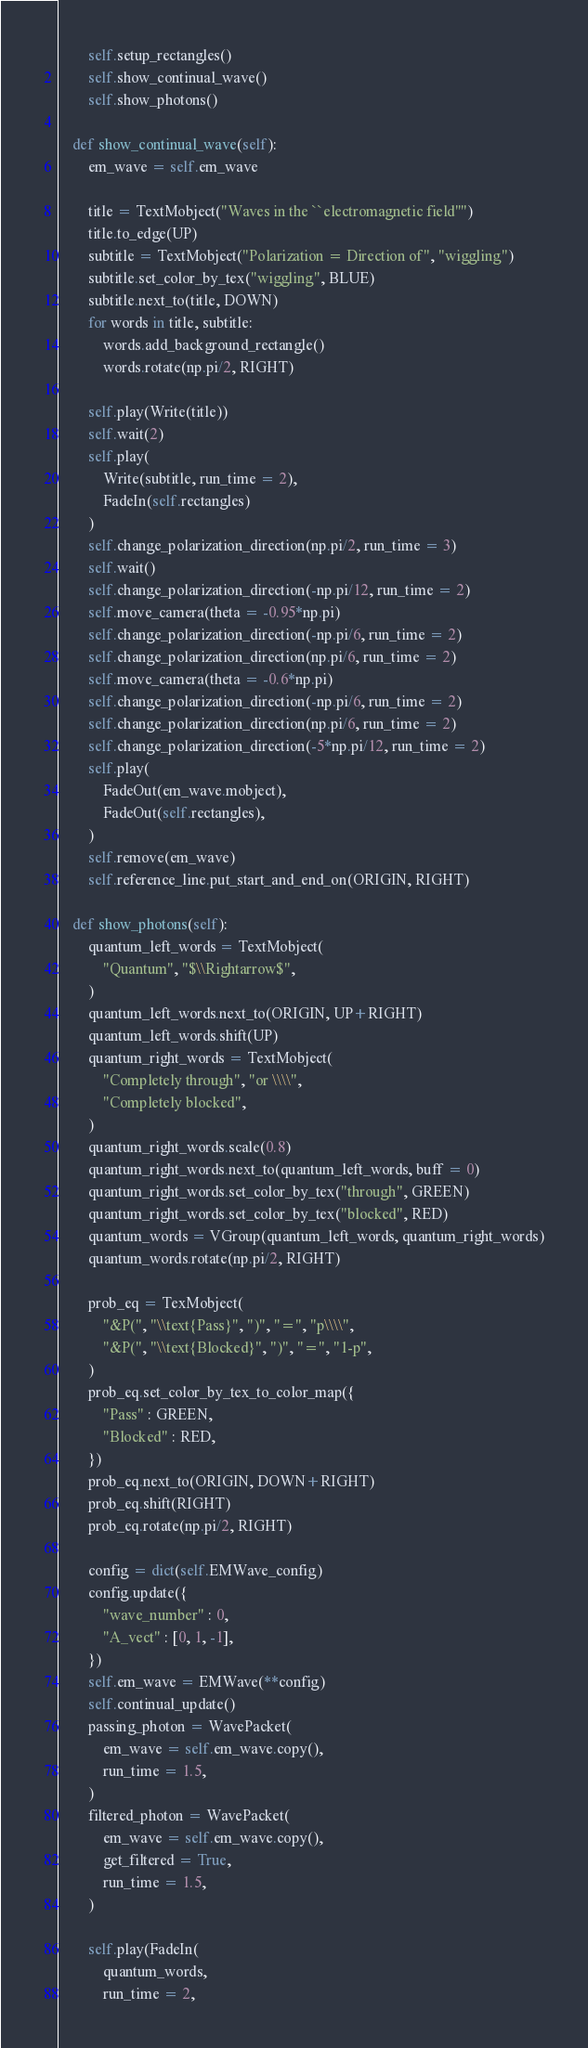Convert code to text. <code><loc_0><loc_0><loc_500><loc_500><_Python_>        self.setup_rectangles()
        self.show_continual_wave()
        self.show_photons()

    def show_continual_wave(self):
        em_wave = self.em_wave

        title = TextMobject("Waves in the ``electromagnetic field''")
        title.to_edge(UP)
        subtitle = TextMobject("Polarization = Direction of", "wiggling")
        subtitle.set_color_by_tex("wiggling", BLUE)
        subtitle.next_to(title, DOWN)
        for words in title, subtitle:
            words.add_background_rectangle()
            words.rotate(np.pi/2, RIGHT)

        self.play(Write(title))
        self.wait(2)
        self.play(
            Write(subtitle, run_time = 2),
            FadeIn(self.rectangles)
        )
        self.change_polarization_direction(np.pi/2, run_time = 3)
        self.wait()
        self.change_polarization_direction(-np.pi/12, run_time = 2)
        self.move_camera(theta = -0.95*np.pi)
        self.change_polarization_direction(-np.pi/6, run_time = 2)
        self.change_polarization_direction(np.pi/6, run_time = 2)
        self.move_camera(theta = -0.6*np.pi)
        self.change_polarization_direction(-np.pi/6, run_time = 2)
        self.change_polarization_direction(np.pi/6, run_time = 2)
        self.change_polarization_direction(-5*np.pi/12, run_time = 2)
        self.play(
            FadeOut(em_wave.mobject),
            FadeOut(self.rectangles),
        )
        self.remove(em_wave)
        self.reference_line.put_start_and_end_on(ORIGIN, RIGHT)

    def show_photons(self):
        quantum_left_words = TextMobject(
            "Quantum", "$\\Rightarrow$",
        )
        quantum_left_words.next_to(ORIGIN, UP+RIGHT)
        quantum_left_words.shift(UP)
        quantum_right_words = TextMobject(
            "Completely through", "or \\\\",
            "Completely blocked",
        )
        quantum_right_words.scale(0.8)
        quantum_right_words.next_to(quantum_left_words, buff = 0)
        quantum_right_words.set_color_by_tex("through", GREEN)
        quantum_right_words.set_color_by_tex("blocked", RED)
        quantum_words = VGroup(quantum_left_words, quantum_right_words)
        quantum_words.rotate(np.pi/2, RIGHT)

        prob_eq = TexMobject(
            "&P(", "\\text{Pass}", ")", "=", "p\\\\",
            "&P(", "\\text{Blocked}", ")", "=", "1-p",
        )
        prob_eq.set_color_by_tex_to_color_map({
            "Pass" : GREEN,
            "Blocked" : RED,
        })
        prob_eq.next_to(ORIGIN, DOWN+RIGHT)
        prob_eq.shift(RIGHT)
        prob_eq.rotate(np.pi/2, RIGHT)

        config = dict(self.EMWave_config)
        config.update({
            "wave_number" : 0,
            "A_vect" : [0, 1, -1],
        })
        self.em_wave = EMWave(**config)
        self.continual_update()
        passing_photon = WavePacket(
            em_wave = self.em_wave.copy(),
            run_time = 1.5,
        )
        filtered_photon = WavePacket(
            em_wave = self.em_wave.copy(),
            get_filtered = True,
            run_time = 1.5,
        )

        self.play(FadeIn(
            quantum_words,
            run_time = 2,</code> 